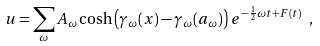Convert formula to latex. <formula><loc_0><loc_0><loc_500><loc_500>u = \sum _ { \omega } A _ { \omega } \cosh \left ( \gamma _ { \omega } ( x ) - \gamma _ { \omega } ( a _ { \omega } ) \right ) \, e ^ { - \frac { 1 } { 2 } \omega t + F ( t ) } \ ,</formula> 